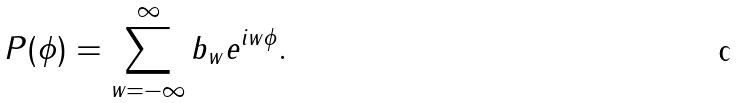Convert formula to latex. <formula><loc_0><loc_0><loc_500><loc_500>P ( \phi ) = \sum _ { w = - \infty } ^ { \infty } b _ { w } e ^ { i w \phi } .</formula> 